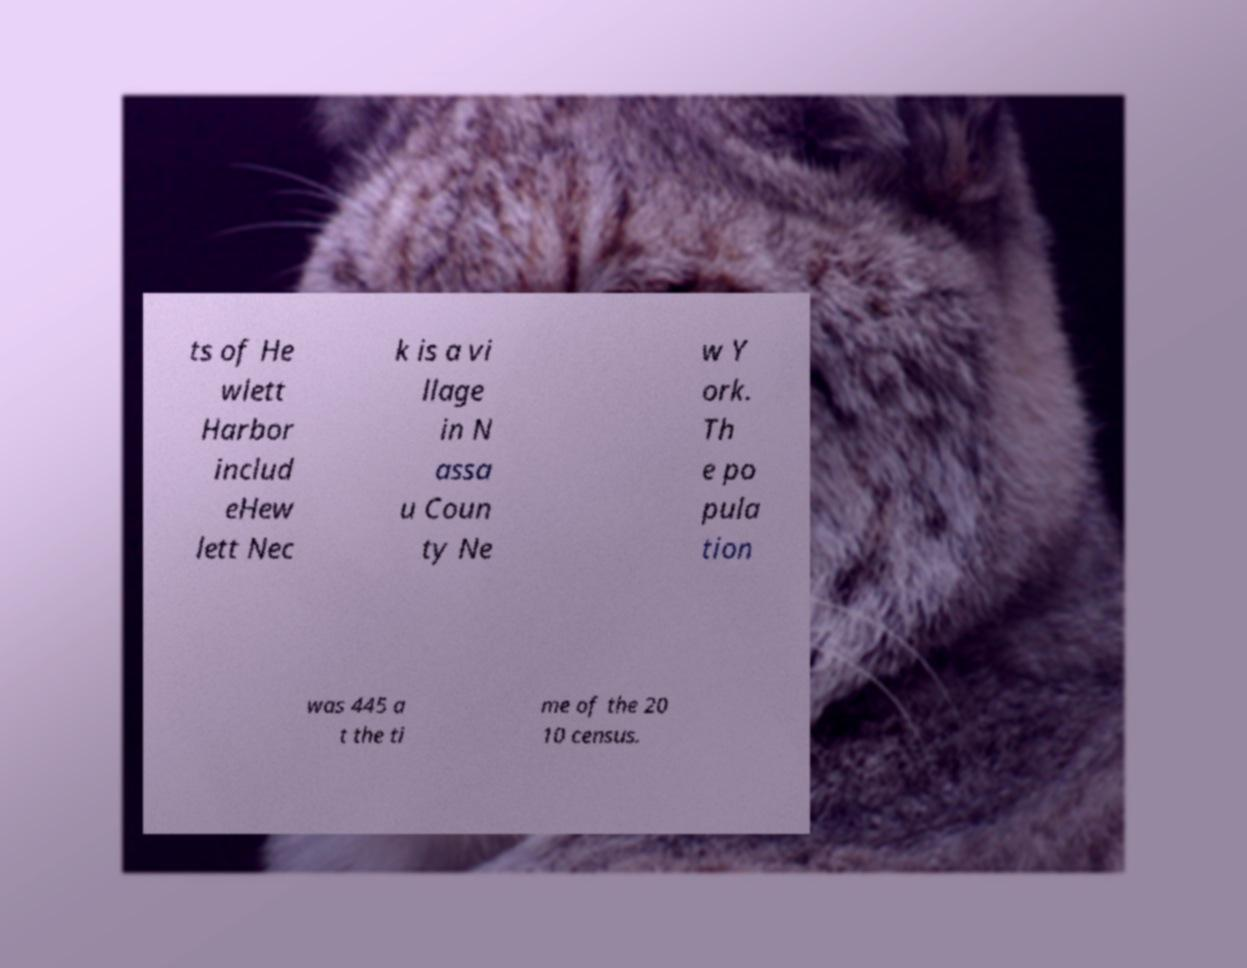Please identify and transcribe the text found in this image. ts of He wlett Harbor includ eHew lett Nec k is a vi llage in N assa u Coun ty Ne w Y ork. Th e po pula tion was 445 a t the ti me of the 20 10 census. 